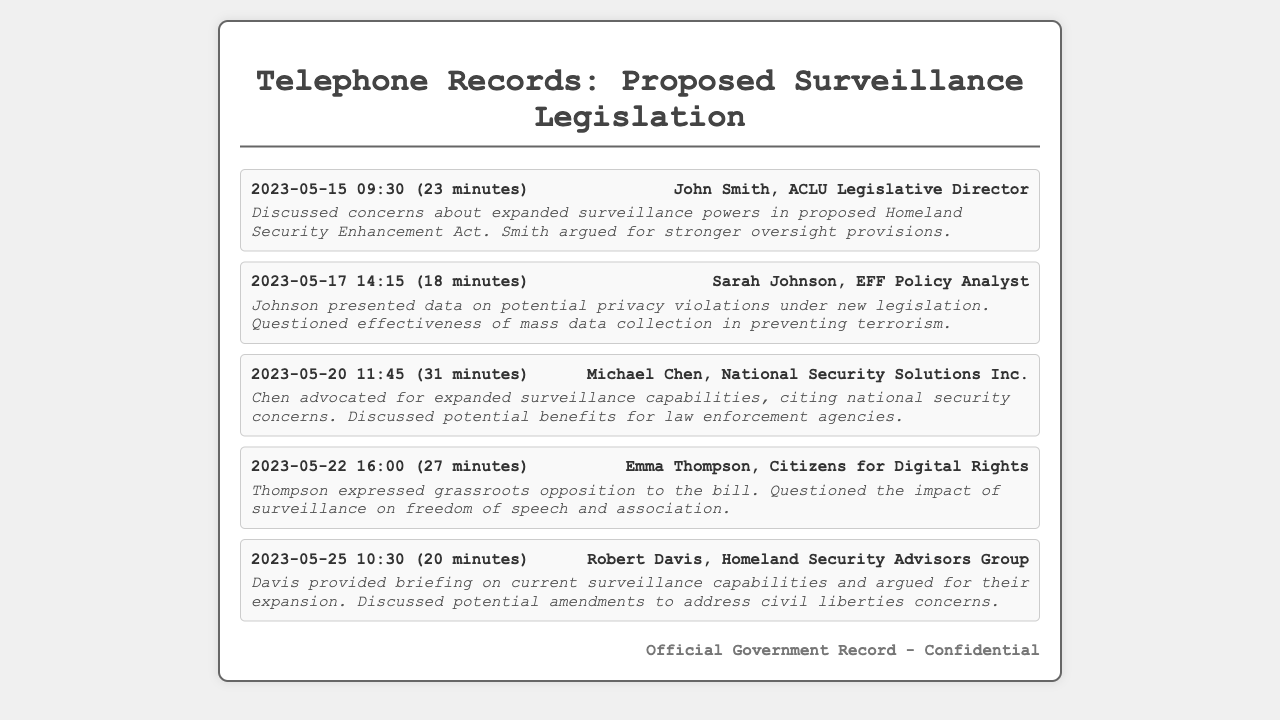What is the date of the first call? The first call entry in the document is dated May 15, 2023.
Answer: May 15, 2023 Who was the ACLU Legislative Director? The call log identifies John Smith as the ACLU Legislative Director.
Answer: John Smith What was the duration of the call with Sarah Johnson? The log shows that the call with Sarah Johnson lasted for 18 minutes.
Answer: 18 minutes Which organization did Emma Thompson represent? Emma Thompson is associated with Citizens for Digital Rights as per the call log.
Answer: Citizens for Digital Rights What concern did Sarah Johnson raise? Johnson questioned the effectiveness of mass data collection in preventing terrorism during her call.
Answer: Effectiveness of mass data collection What was Robert Davis's role? Robert Davis was identified as a member of the Homeland Security Advisors Group in the document.
Answer: Homeland Security Advisors Group During which call was national security cited as a concern? The call with Michael Chen discussed expanded surveillance capabilities citing national security concerns.
Answer: Michael Chen How many total calls are documented? The call log contains a total of five entries.
Answer: Five What was a key point of Emma Thompson's conversation? Thompson expressed grassroots opposition to the bill, questioning its impact on freedom of speech.
Answer: Freedom of speech and association 